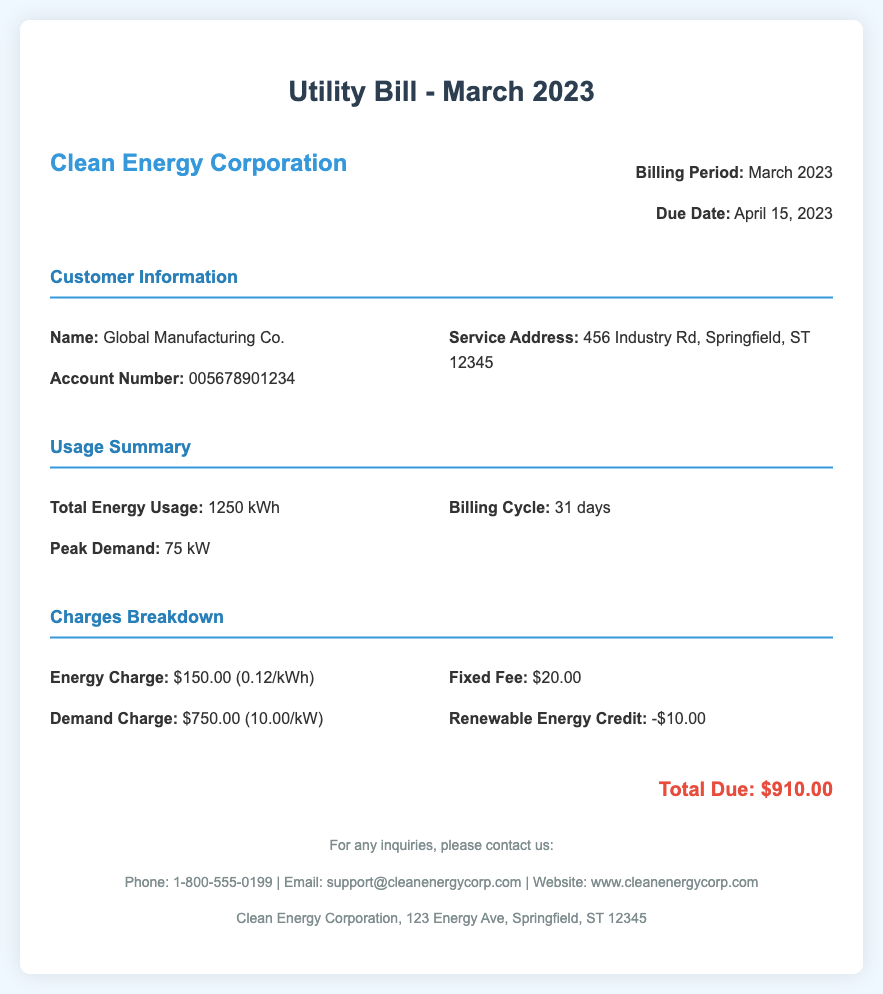What is the billing period? The billing period for the utility bill is specified in the document.
Answer: March 2023 What is the total energy usage? The total energy usage is mentioned in the usage summary section of the document.
Answer: 1250 kWh What is the peak demand? The peak demand is listed in the usage summary section of the document.
Answer: 75 kW What is the due date for the bill? The due date is stated in the billing information at the top of the document.
Answer: April 15, 2023 How much is the energy charge? The energy charge can be found in the charges breakdown section of the document.
Answer: $150.00 What is the fixed fee? The fixed fee is included in the charges breakdown section of the document.
Answer: $20.00 What is the total amount due? The total amount due is clearly stated at the bottom of the document.
Answer: $910.00 How many days are in the billing cycle? The number of days in the billing cycle is mentioned in the usage summary section.
Answer: 31 days What is the renewable energy credit amount? The renewable energy credit amount is part of the charges breakdown in the document.
Answer: -$10.00 